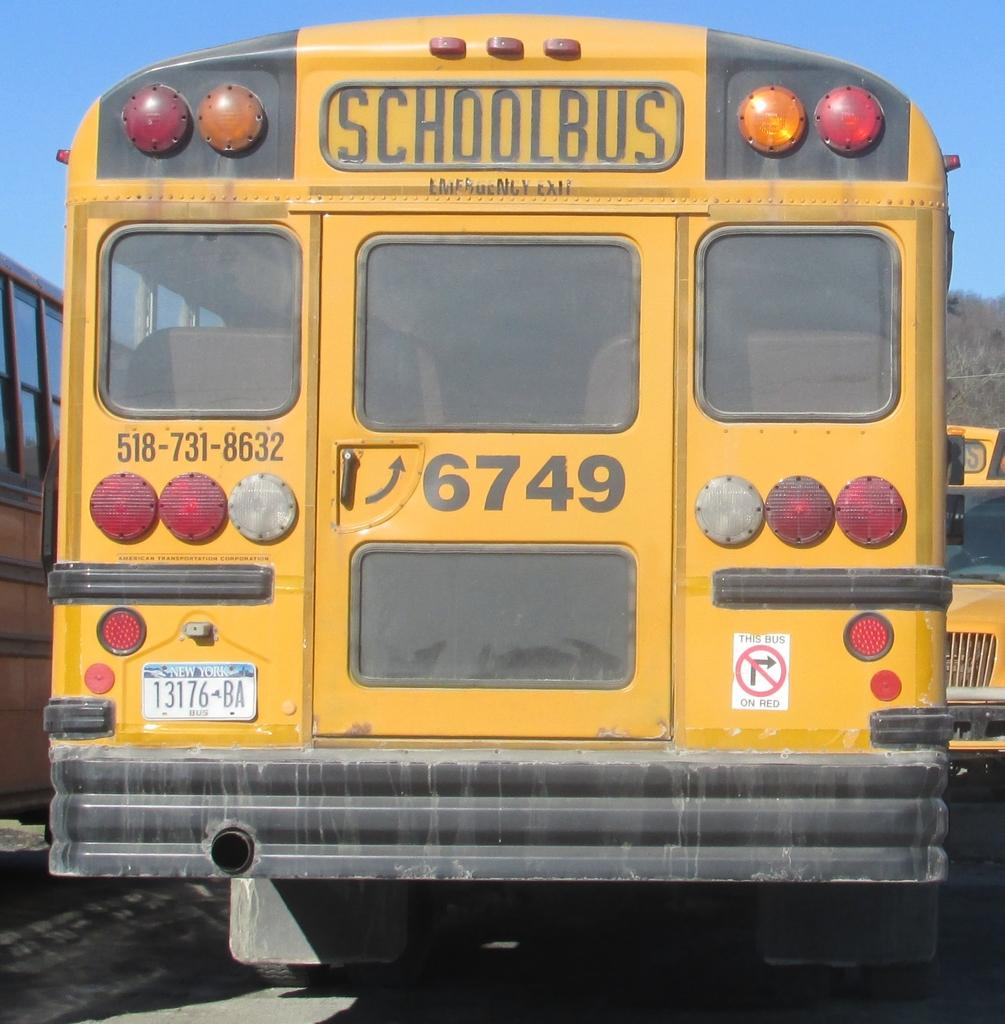<image>
Share a concise interpretation of the image provided. A large yellow school bus with the number 6749 